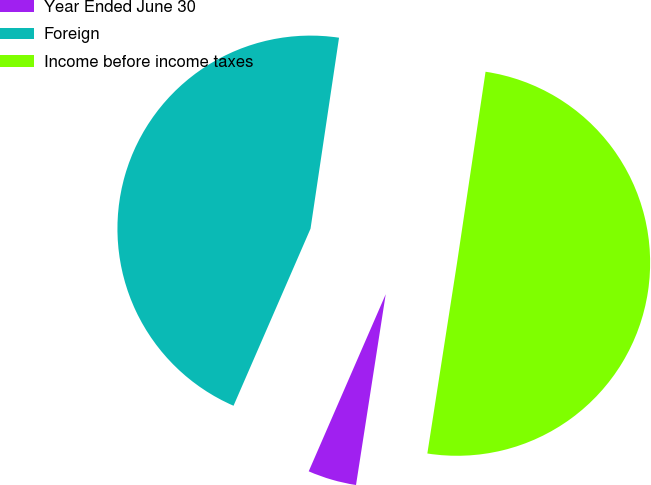Convert chart. <chart><loc_0><loc_0><loc_500><loc_500><pie_chart><fcel>Year Ended June 30<fcel>Foreign<fcel>Income before income taxes<nl><fcel>4.07%<fcel>45.83%<fcel>50.1%<nl></chart> 